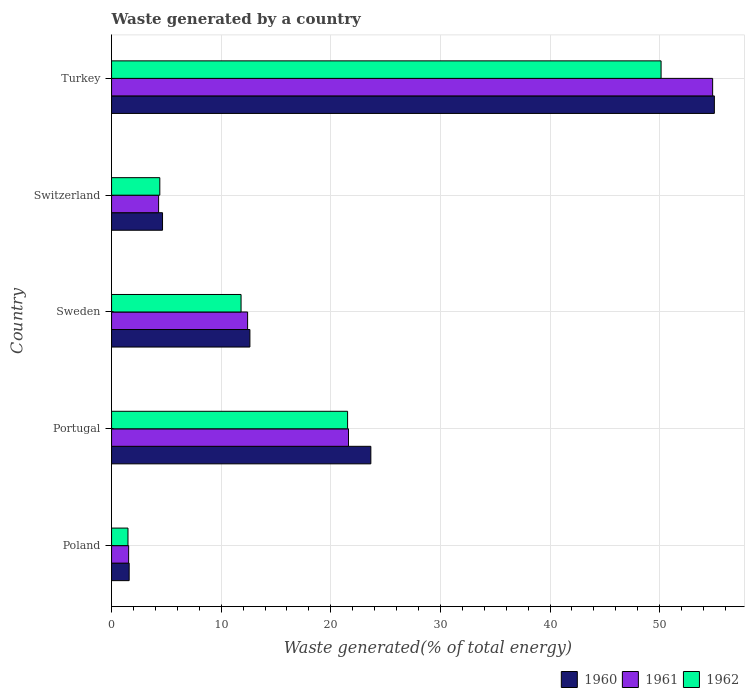How many groups of bars are there?
Your answer should be very brief. 5. Are the number of bars per tick equal to the number of legend labels?
Your response must be concise. Yes. Are the number of bars on each tick of the Y-axis equal?
Ensure brevity in your answer.  Yes. How many bars are there on the 4th tick from the top?
Provide a succinct answer. 3. How many bars are there on the 5th tick from the bottom?
Offer a terse response. 3. What is the label of the 4th group of bars from the top?
Provide a short and direct response. Portugal. In how many cases, is the number of bars for a given country not equal to the number of legend labels?
Your response must be concise. 0. What is the total waste generated in 1962 in Switzerland?
Your answer should be very brief. 4.4. Across all countries, what is the maximum total waste generated in 1961?
Give a very brief answer. 54.84. Across all countries, what is the minimum total waste generated in 1960?
Make the answer very short. 1.6. What is the total total waste generated in 1962 in the graph?
Offer a very short reply. 89.39. What is the difference between the total waste generated in 1961 in Poland and that in Turkey?
Provide a succinct answer. -53.28. What is the difference between the total waste generated in 1962 in Turkey and the total waste generated in 1960 in Portugal?
Make the answer very short. 26.48. What is the average total waste generated in 1960 per country?
Provide a short and direct response. 19.51. What is the difference between the total waste generated in 1960 and total waste generated in 1961 in Switzerland?
Ensure brevity in your answer.  0.36. In how many countries, is the total waste generated in 1961 greater than 16 %?
Your answer should be compact. 2. What is the ratio of the total waste generated in 1960 in Switzerland to that in Turkey?
Ensure brevity in your answer.  0.08. Is the total waste generated in 1961 in Portugal less than that in Switzerland?
Ensure brevity in your answer.  No. What is the difference between the highest and the second highest total waste generated in 1961?
Your answer should be compact. 33.22. What is the difference between the highest and the lowest total waste generated in 1962?
Ensure brevity in your answer.  48.64. In how many countries, is the total waste generated in 1962 greater than the average total waste generated in 1962 taken over all countries?
Ensure brevity in your answer.  2. What does the 1st bar from the top in Portugal represents?
Offer a terse response. 1962. How many bars are there?
Keep it short and to the point. 15. What is the difference between two consecutive major ticks on the X-axis?
Provide a succinct answer. 10. Does the graph contain grids?
Your answer should be compact. Yes. How many legend labels are there?
Ensure brevity in your answer.  3. What is the title of the graph?
Your answer should be very brief. Waste generated by a country. What is the label or title of the X-axis?
Provide a short and direct response. Waste generated(% of total energy). What is the Waste generated(% of total energy) in 1960 in Poland?
Give a very brief answer. 1.6. What is the Waste generated(% of total energy) in 1961 in Poland?
Your answer should be compact. 1.56. What is the Waste generated(% of total energy) in 1962 in Poland?
Ensure brevity in your answer.  1.5. What is the Waste generated(% of total energy) in 1960 in Portugal?
Your answer should be very brief. 23.66. What is the Waste generated(% of total energy) in 1961 in Portugal?
Ensure brevity in your answer.  21.62. What is the Waste generated(% of total energy) of 1962 in Portugal?
Your answer should be compact. 21.53. What is the Waste generated(% of total energy) of 1960 in Sweden?
Ensure brevity in your answer.  12.62. What is the Waste generated(% of total energy) in 1961 in Sweden?
Give a very brief answer. 12.41. What is the Waste generated(% of total energy) of 1962 in Sweden?
Your answer should be very brief. 11.82. What is the Waste generated(% of total energy) in 1960 in Switzerland?
Offer a very short reply. 4.65. What is the Waste generated(% of total energy) of 1961 in Switzerland?
Your response must be concise. 4.29. What is the Waste generated(% of total energy) in 1962 in Switzerland?
Give a very brief answer. 4.4. What is the Waste generated(% of total energy) of 1960 in Turkey?
Ensure brevity in your answer.  54.99. What is the Waste generated(% of total energy) of 1961 in Turkey?
Give a very brief answer. 54.84. What is the Waste generated(% of total energy) of 1962 in Turkey?
Provide a short and direct response. 50.13. Across all countries, what is the maximum Waste generated(% of total energy) of 1960?
Give a very brief answer. 54.99. Across all countries, what is the maximum Waste generated(% of total energy) in 1961?
Provide a short and direct response. 54.84. Across all countries, what is the maximum Waste generated(% of total energy) of 1962?
Provide a short and direct response. 50.13. Across all countries, what is the minimum Waste generated(% of total energy) in 1960?
Offer a terse response. 1.6. Across all countries, what is the minimum Waste generated(% of total energy) in 1961?
Offer a terse response. 1.56. Across all countries, what is the minimum Waste generated(% of total energy) of 1962?
Your answer should be compact. 1.5. What is the total Waste generated(% of total energy) in 1960 in the graph?
Your answer should be compact. 97.53. What is the total Waste generated(% of total energy) of 1961 in the graph?
Provide a short and direct response. 94.72. What is the total Waste generated(% of total energy) of 1962 in the graph?
Give a very brief answer. 89.39. What is the difference between the Waste generated(% of total energy) of 1960 in Poland and that in Portugal?
Your response must be concise. -22.05. What is the difference between the Waste generated(% of total energy) in 1961 in Poland and that in Portugal?
Your response must be concise. -20.06. What is the difference between the Waste generated(% of total energy) of 1962 in Poland and that in Portugal?
Provide a short and direct response. -20.03. What is the difference between the Waste generated(% of total energy) of 1960 in Poland and that in Sweden?
Keep it short and to the point. -11.02. What is the difference between the Waste generated(% of total energy) in 1961 in Poland and that in Sweden?
Offer a terse response. -10.85. What is the difference between the Waste generated(% of total energy) in 1962 in Poland and that in Sweden?
Your answer should be compact. -10.32. What is the difference between the Waste generated(% of total energy) of 1960 in Poland and that in Switzerland?
Offer a terse response. -3.04. What is the difference between the Waste generated(% of total energy) in 1961 in Poland and that in Switzerland?
Make the answer very short. -2.73. What is the difference between the Waste generated(% of total energy) in 1962 in Poland and that in Switzerland?
Keep it short and to the point. -2.9. What is the difference between the Waste generated(% of total energy) of 1960 in Poland and that in Turkey?
Keep it short and to the point. -53.39. What is the difference between the Waste generated(% of total energy) of 1961 in Poland and that in Turkey?
Your response must be concise. -53.28. What is the difference between the Waste generated(% of total energy) of 1962 in Poland and that in Turkey?
Your answer should be compact. -48.64. What is the difference between the Waste generated(% of total energy) in 1960 in Portugal and that in Sweden?
Provide a short and direct response. 11.03. What is the difference between the Waste generated(% of total energy) in 1961 in Portugal and that in Sweden?
Your answer should be very brief. 9.2. What is the difference between the Waste generated(% of total energy) in 1962 in Portugal and that in Sweden?
Provide a short and direct response. 9.72. What is the difference between the Waste generated(% of total energy) in 1960 in Portugal and that in Switzerland?
Give a very brief answer. 19.01. What is the difference between the Waste generated(% of total energy) in 1961 in Portugal and that in Switzerland?
Your answer should be very brief. 17.32. What is the difference between the Waste generated(% of total energy) of 1962 in Portugal and that in Switzerland?
Your answer should be very brief. 17.13. What is the difference between the Waste generated(% of total energy) in 1960 in Portugal and that in Turkey?
Your answer should be very brief. -31.34. What is the difference between the Waste generated(% of total energy) in 1961 in Portugal and that in Turkey?
Keep it short and to the point. -33.22. What is the difference between the Waste generated(% of total energy) of 1962 in Portugal and that in Turkey?
Make the answer very short. -28.6. What is the difference between the Waste generated(% of total energy) of 1960 in Sweden and that in Switzerland?
Offer a very short reply. 7.97. What is the difference between the Waste generated(% of total energy) of 1961 in Sweden and that in Switzerland?
Provide a short and direct response. 8.12. What is the difference between the Waste generated(% of total energy) in 1962 in Sweden and that in Switzerland?
Offer a very short reply. 7.41. What is the difference between the Waste generated(% of total energy) in 1960 in Sweden and that in Turkey?
Offer a very short reply. -42.37. What is the difference between the Waste generated(% of total energy) of 1961 in Sweden and that in Turkey?
Your response must be concise. -42.43. What is the difference between the Waste generated(% of total energy) of 1962 in Sweden and that in Turkey?
Give a very brief answer. -38.32. What is the difference between the Waste generated(% of total energy) in 1960 in Switzerland and that in Turkey?
Offer a terse response. -50.34. What is the difference between the Waste generated(% of total energy) in 1961 in Switzerland and that in Turkey?
Keep it short and to the point. -50.55. What is the difference between the Waste generated(% of total energy) of 1962 in Switzerland and that in Turkey?
Make the answer very short. -45.73. What is the difference between the Waste generated(% of total energy) in 1960 in Poland and the Waste generated(% of total energy) in 1961 in Portugal?
Keep it short and to the point. -20.01. What is the difference between the Waste generated(% of total energy) of 1960 in Poland and the Waste generated(% of total energy) of 1962 in Portugal?
Your response must be concise. -19.93. What is the difference between the Waste generated(% of total energy) of 1961 in Poland and the Waste generated(% of total energy) of 1962 in Portugal?
Keep it short and to the point. -19.98. What is the difference between the Waste generated(% of total energy) in 1960 in Poland and the Waste generated(% of total energy) in 1961 in Sweden?
Offer a terse response. -10.81. What is the difference between the Waste generated(% of total energy) of 1960 in Poland and the Waste generated(% of total energy) of 1962 in Sweden?
Make the answer very short. -10.21. What is the difference between the Waste generated(% of total energy) in 1961 in Poland and the Waste generated(% of total energy) in 1962 in Sweden?
Provide a short and direct response. -10.26. What is the difference between the Waste generated(% of total energy) of 1960 in Poland and the Waste generated(% of total energy) of 1961 in Switzerland?
Make the answer very short. -2.69. What is the difference between the Waste generated(% of total energy) in 1960 in Poland and the Waste generated(% of total energy) in 1962 in Switzerland?
Offer a very short reply. -2.8. What is the difference between the Waste generated(% of total energy) in 1961 in Poland and the Waste generated(% of total energy) in 1962 in Switzerland?
Provide a short and direct response. -2.84. What is the difference between the Waste generated(% of total energy) in 1960 in Poland and the Waste generated(% of total energy) in 1961 in Turkey?
Provide a succinct answer. -53.23. What is the difference between the Waste generated(% of total energy) in 1960 in Poland and the Waste generated(% of total energy) in 1962 in Turkey?
Your answer should be very brief. -48.53. What is the difference between the Waste generated(% of total energy) in 1961 in Poland and the Waste generated(% of total energy) in 1962 in Turkey?
Provide a short and direct response. -48.58. What is the difference between the Waste generated(% of total energy) in 1960 in Portugal and the Waste generated(% of total energy) in 1961 in Sweden?
Offer a very short reply. 11.24. What is the difference between the Waste generated(% of total energy) in 1960 in Portugal and the Waste generated(% of total energy) in 1962 in Sweden?
Offer a very short reply. 11.84. What is the difference between the Waste generated(% of total energy) of 1961 in Portugal and the Waste generated(% of total energy) of 1962 in Sweden?
Offer a terse response. 9.8. What is the difference between the Waste generated(% of total energy) of 1960 in Portugal and the Waste generated(% of total energy) of 1961 in Switzerland?
Offer a terse response. 19.36. What is the difference between the Waste generated(% of total energy) of 1960 in Portugal and the Waste generated(% of total energy) of 1962 in Switzerland?
Keep it short and to the point. 19.25. What is the difference between the Waste generated(% of total energy) in 1961 in Portugal and the Waste generated(% of total energy) in 1962 in Switzerland?
Offer a very short reply. 17.21. What is the difference between the Waste generated(% of total energy) of 1960 in Portugal and the Waste generated(% of total energy) of 1961 in Turkey?
Provide a short and direct response. -31.18. What is the difference between the Waste generated(% of total energy) of 1960 in Portugal and the Waste generated(% of total energy) of 1962 in Turkey?
Keep it short and to the point. -26.48. What is the difference between the Waste generated(% of total energy) in 1961 in Portugal and the Waste generated(% of total energy) in 1962 in Turkey?
Your answer should be very brief. -28.52. What is the difference between the Waste generated(% of total energy) of 1960 in Sweden and the Waste generated(% of total energy) of 1961 in Switzerland?
Give a very brief answer. 8.33. What is the difference between the Waste generated(% of total energy) of 1960 in Sweden and the Waste generated(% of total energy) of 1962 in Switzerland?
Your response must be concise. 8.22. What is the difference between the Waste generated(% of total energy) of 1961 in Sweden and the Waste generated(% of total energy) of 1962 in Switzerland?
Provide a short and direct response. 8.01. What is the difference between the Waste generated(% of total energy) of 1960 in Sweden and the Waste generated(% of total energy) of 1961 in Turkey?
Provide a short and direct response. -42.22. What is the difference between the Waste generated(% of total energy) of 1960 in Sweden and the Waste generated(% of total energy) of 1962 in Turkey?
Offer a terse response. -37.51. What is the difference between the Waste generated(% of total energy) of 1961 in Sweden and the Waste generated(% of total energy) of 1962 in Turkey?
Ensure brevity in your answer.  -37.72. What is the difference between the Waste generated(% of total energy) of 1960 in Switzerland and the Waste generated(% of total energy) of 1961 in Turkey?
Your answer should be compact. -50.19. What is the difference between the Waste generated(% of total energy) in 1960 in Switzerland and the Waste generated(% of total energy) in 1962 in Turkey?
Offer a terse response. -45.48. What is the difference between the Waste generated(% of total energy) of 1961 in Switzerland and the Waste generated(% of total energy) of 1962 in Turkey?
Provide a succinct answer. -45.84. What is the average Waste generated(% of total energy) in 1960 per country?
Provide a succinct answer. 19.51. What is the average Waste generated(% of total energy) in 1961 per country?
Offer a very short reply. 18.94. What is the average Waste generated(% of total energy) in 1962 per country?
Provide a short and direct response. 17.88. What is the difference between the Waste generated(% of total energy) of 1960 and Waste generated(% of total energy) of 1961 in Poland?
Make the answer very short. 0.05. What is the difference between the Waste generated(% of total energy) of 1960 and Waste generated(% of total energy) of 1962 in Poland?
Keep it short and to the point. 0.11. What is the difference between the Waste generated(% of total energy) of 1961 and Waste generated(% of total energy) of 1962 in Poland?
Your answer should be very brief. 0.06. What is the difference between the Waste generated(% of total energy) of 1960 and Waste generated(% of total energy) of 1961 in Portugal?
Your answer should be very brief. 2.04. What is the difference between the Waste generated(% of total energy) in 1960 and Waste generated(% of total energy) in 1962 in Portugal?
Offer a terse response. 2.12. What is the difference between the Waste generated(% of total energy) in 1961 and Waste generated(% of total energy) in 1962 in Portugal?
Ensure brevity in your answer.  0.08. What is the difference between the Waste generated(% of total energy) of 1960 and Waste generated(% of total energy) of 1961 in Sweden?
Provide a succinct answer. 0.21. What is the difference between the Waste generated(% of total energy) of 1960 and Waste generated(% of total energy) of 1962 in Sweden?
Your answer should be very brief. 0.81. What is the difference between the Waste generated(% of total energy) of 1961 and Waste generated(% of total energy) of 1962 in Sweden?
Give a very brief answer. 0.6. What is the difference between the Waste generated(% of total energy) in 1960 and Waste generated(% of total energy) in 1961 in Switzerland?
Your response must be concise. 0.36. What is the difference between the Waste generated(% of total energy) in 1960 and Waste generated(% of total energy) in 1962 in Switzerland?
Your answer should be very brief. 0.25. What is the difference between the Waste generated(% of total energy) in 1961 and Waste generated(% of total energy) in 1962 in Switzerland?
Your answer should be very brief. -0.11. What is the difference between the Waste generated(% of total energy) of 1960 and Waste generated(% of total energy) of 1961 in Turkey?
Ensure brevity in your answer.  0.16. What is the difference between the Waste generated(% of total energy) in 1960 and Waste generated(% of total energy) in 1962 in Turkey?
Ensure brevity in your answer.  4.86. What is the difference between the Waste generated(% of total energy) of 1961 and Waste generated(% of total energy) of 1962 in Turkey?
Keep it short and to the point. 4.7. What is the ratio of the Waste generated(% of total energy) of 1960 in Poland to that in Portugal?
Offer a very short reply. 0.07. What is the ratio of the Waste generated(% of total energy) of 1961 in Poland to that in Portugal?
Provide a succinct answer. 0.07. What is the ratio of the Waste generated(% of total energy) in 1962 in Poland to that in Portugal?
Give a very brief answer. 0.07. What is the ratio of the Waste generated(% of total energy) of 1960 in Poland to that in Sweden?
Your answer should be very brief. 0.13. What is the ratio of the Waste generated(% of total energy) of 1961 in Poland to that in Sweden?
Your answer should be very brief. 0.13. What is the ratio of the Waste generated(% of total energy) in 1962 in Poland to that in Sweden?
Offer a terse response. 0.13. What is the ratio of the Waste generated(% of total energy) in 1960 in Poland to that in Switzerland?
Your response must be concise. 0.35. What is the ratio of the Waste generated(% of total energy) in 1961 in Poland to that in Switzerland?
Ensure brevity in your answer.  0.36. What is the ratio of the Waste generated(% of total energy) in 1962 in Poland to that in Switzerland?
Provide a succinct answer. 0.34. What is the ratio of the Waste generated(% of total energy) of 1960 in Poland to that in Turkey?
Provide a succinct answer. 0.03. What is the ratio of the Waste generated(% of total energy) in 1961 in Poland to that in Turkey?
Provide a short and direct response. 0.03. What is the ratio of the Waste generated(% of total energy) in 1962 in Poland to that in Turkey?
Provide a succinct answer. 0.03. What is the ratio of the Waste generated(% of total energy) in 1960 in Portugal to that in Sweden?
Offer a terse response. 1.87. What is the ratio of the Waste generated(% of total energy) in 1961 in Portugal to that in Sweden?
Your answer should be compact. 1.74. What is the ratio of the Waste generated(% of total energy) of 1962 in Portugal to that in Sweden?
Offer a very short reply. 1.82. What is the ratio of the Waste generated(% of total energy) of 1960 in Portugal to that in Switzerland?
Offer a terse response. 5.09. What is the ratio of the Waste generated(% of total energy) of 1961 in Portugal to that in Switzerland?
Your answer should be compact. 5.04. What is the ratio of the Waste generated(% of total energy) of 1962 in Portugal to that in Switzerland?
Give a very brief answer. 4.89. What is the ratio of the Waste generated(% of total energy) of 1960 in Portugal to that in Turkey?
Provide a short and direct response. 0.43. What is the ratio of the Waste generated(% of total energy) of 1961 in Portugal to that in Turkey?
Your answer should be compact. 0.39. What is the ratio of the Waste generated(% of total energy) in 1962 in Portugal to that in Turkey?
Offer a very short reply. 0.43. What is the ratio of the Waste generated(% of total energy) of 1960 in Sweden to that in Switzerland?
Provide a succinct answer. 2.71. What is the ratio of the Waste generated(% of total energy) of 1961 in Sweden to that in Switzerland?
Give a very brief answer. 2.89. What is the ratio of the Waste generated(% of total energy) in 1962 in Sweden to that in Switzerland?
Make the answer very short. 2.68. What is the ratio of the Waste generated(% of total energy) in 1960 in Sweden to that in Turkey?
Offer a terse response. 0.23. What is the ratio of the Waste generated(% of total energy) of 1961 in Sweden to that in Turkey?
Your answer should be very brief. 0.23. What is the ratio of the Waste generated(% of total energy) in 1962 in Sweden to that in Turkey?
Provide a succinct answer. 0.24. What is the ratio of the Waste generated(% of total energy) in 1960 in Switzerland to that in Turkey?
Your response must be concise. 0.08. What is the ratio of the Waste generated(% of total energy) of 1961 in Switzerland to that in Turkey?
Give a very brief answer. 0.08. What is the ratio of the Waste generated(% of total energy) in 1962 in Switzerland to that in Turkey?
Your answer should be compact. 0.09. What is the difference between the highest and the second highest Waste generated(% of total energy) of 1960?
Give a very brief answer. 31.34. What is the difference between the highest and the second highest Waste generated(% of total energy) in 1961?
Offer a very short reply. 33.22. What is the difference between the highest and the second highest Waste generated(% of total energy) in 1962?
Your answer should be compact. 28.6. What is the difference between the highest and the lowest Waste generated(% of total energy) in 1960?
Your answer should be very brief. 53.39. What is the difference between the highest and the lowest Waste generated(% of total energy) in 1961?
Your answer should be very brief. 53.28. What is the difference between the highest and the lowest Waste generated(% of total energy) in 1962?
Ensure brevity in your answer.  48.64. 